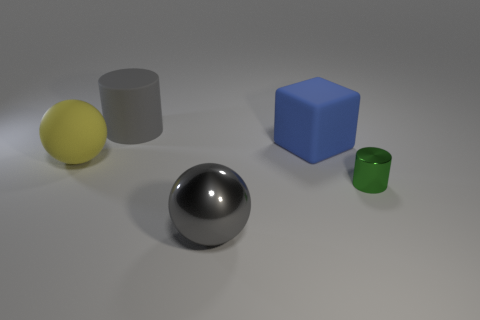Is the number of spheres in front of the gray metallic object greater than the number of big gray metallic objects?
Offer a terse response. No. The yellow rubber object has what shape?
Provide a succinct answer. Sphere. There is a cylinder behind the large yellow sphere; is it the same color as the metal thing that is left of the block?
Your answer should be compact. Yes. Does the yellow object have the same shape as the big blue object?
Keep it short and to the point. No. Are there any other things that are the same shape as the green metal thing?
Your answer should be very brief. Yes. Does the cylinder that is on the left side of the rubber cube have the same material as the big gray ball?
Your response must be concise. No. What shape is the thing that is in front of the blue object and behind the green metallic cylinder?
Your answer should be compact. Sphere. There is a cylinder that is right of the gray cylinder; is there a metallic thing on the right side of it?
Make the answer very short. No. What number of other objects are the same material as the large blue cube?
Offer a terse response. 2. Do the big gray object behind the tiny metallic thing and the gray thing that is in front of the big blue thing have the same shape?
Your response must be concise. No. 